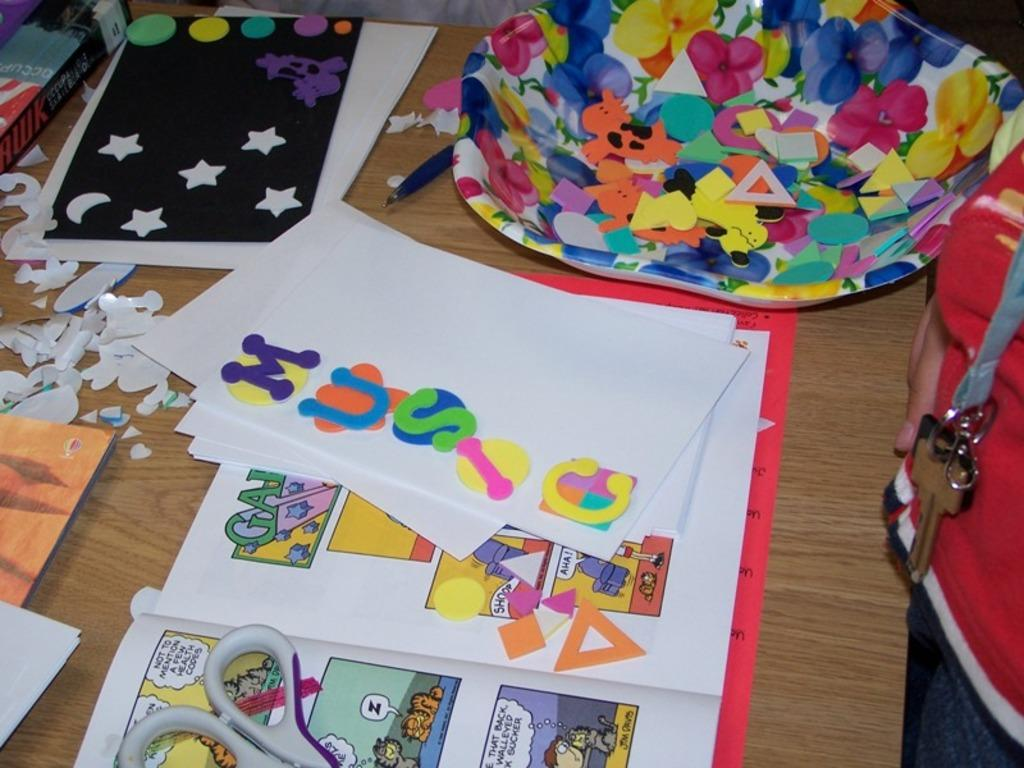What type of objects can be seen on the table in the image? There are books, papers, a scissor, a pen, and alphabets on the table in the image. What is the purpose of the pen in the image? The pen in the image is likely used for writing or drawing. What is the dish used for in the image? The purpose of the dish in the image is not clear, but it could be used for holding small objects or serving food. Can you describe the person standing on the right side of the image? Unfortunately, the facts provided do not give any details about the person's appearance or clothing. How many beds can be seen in the image? There are no beds present in the image. What type of twig is being used to write on the papers in the image? There is no twig visible in the image; the pen is the writing instrument mentioned in the facts. 